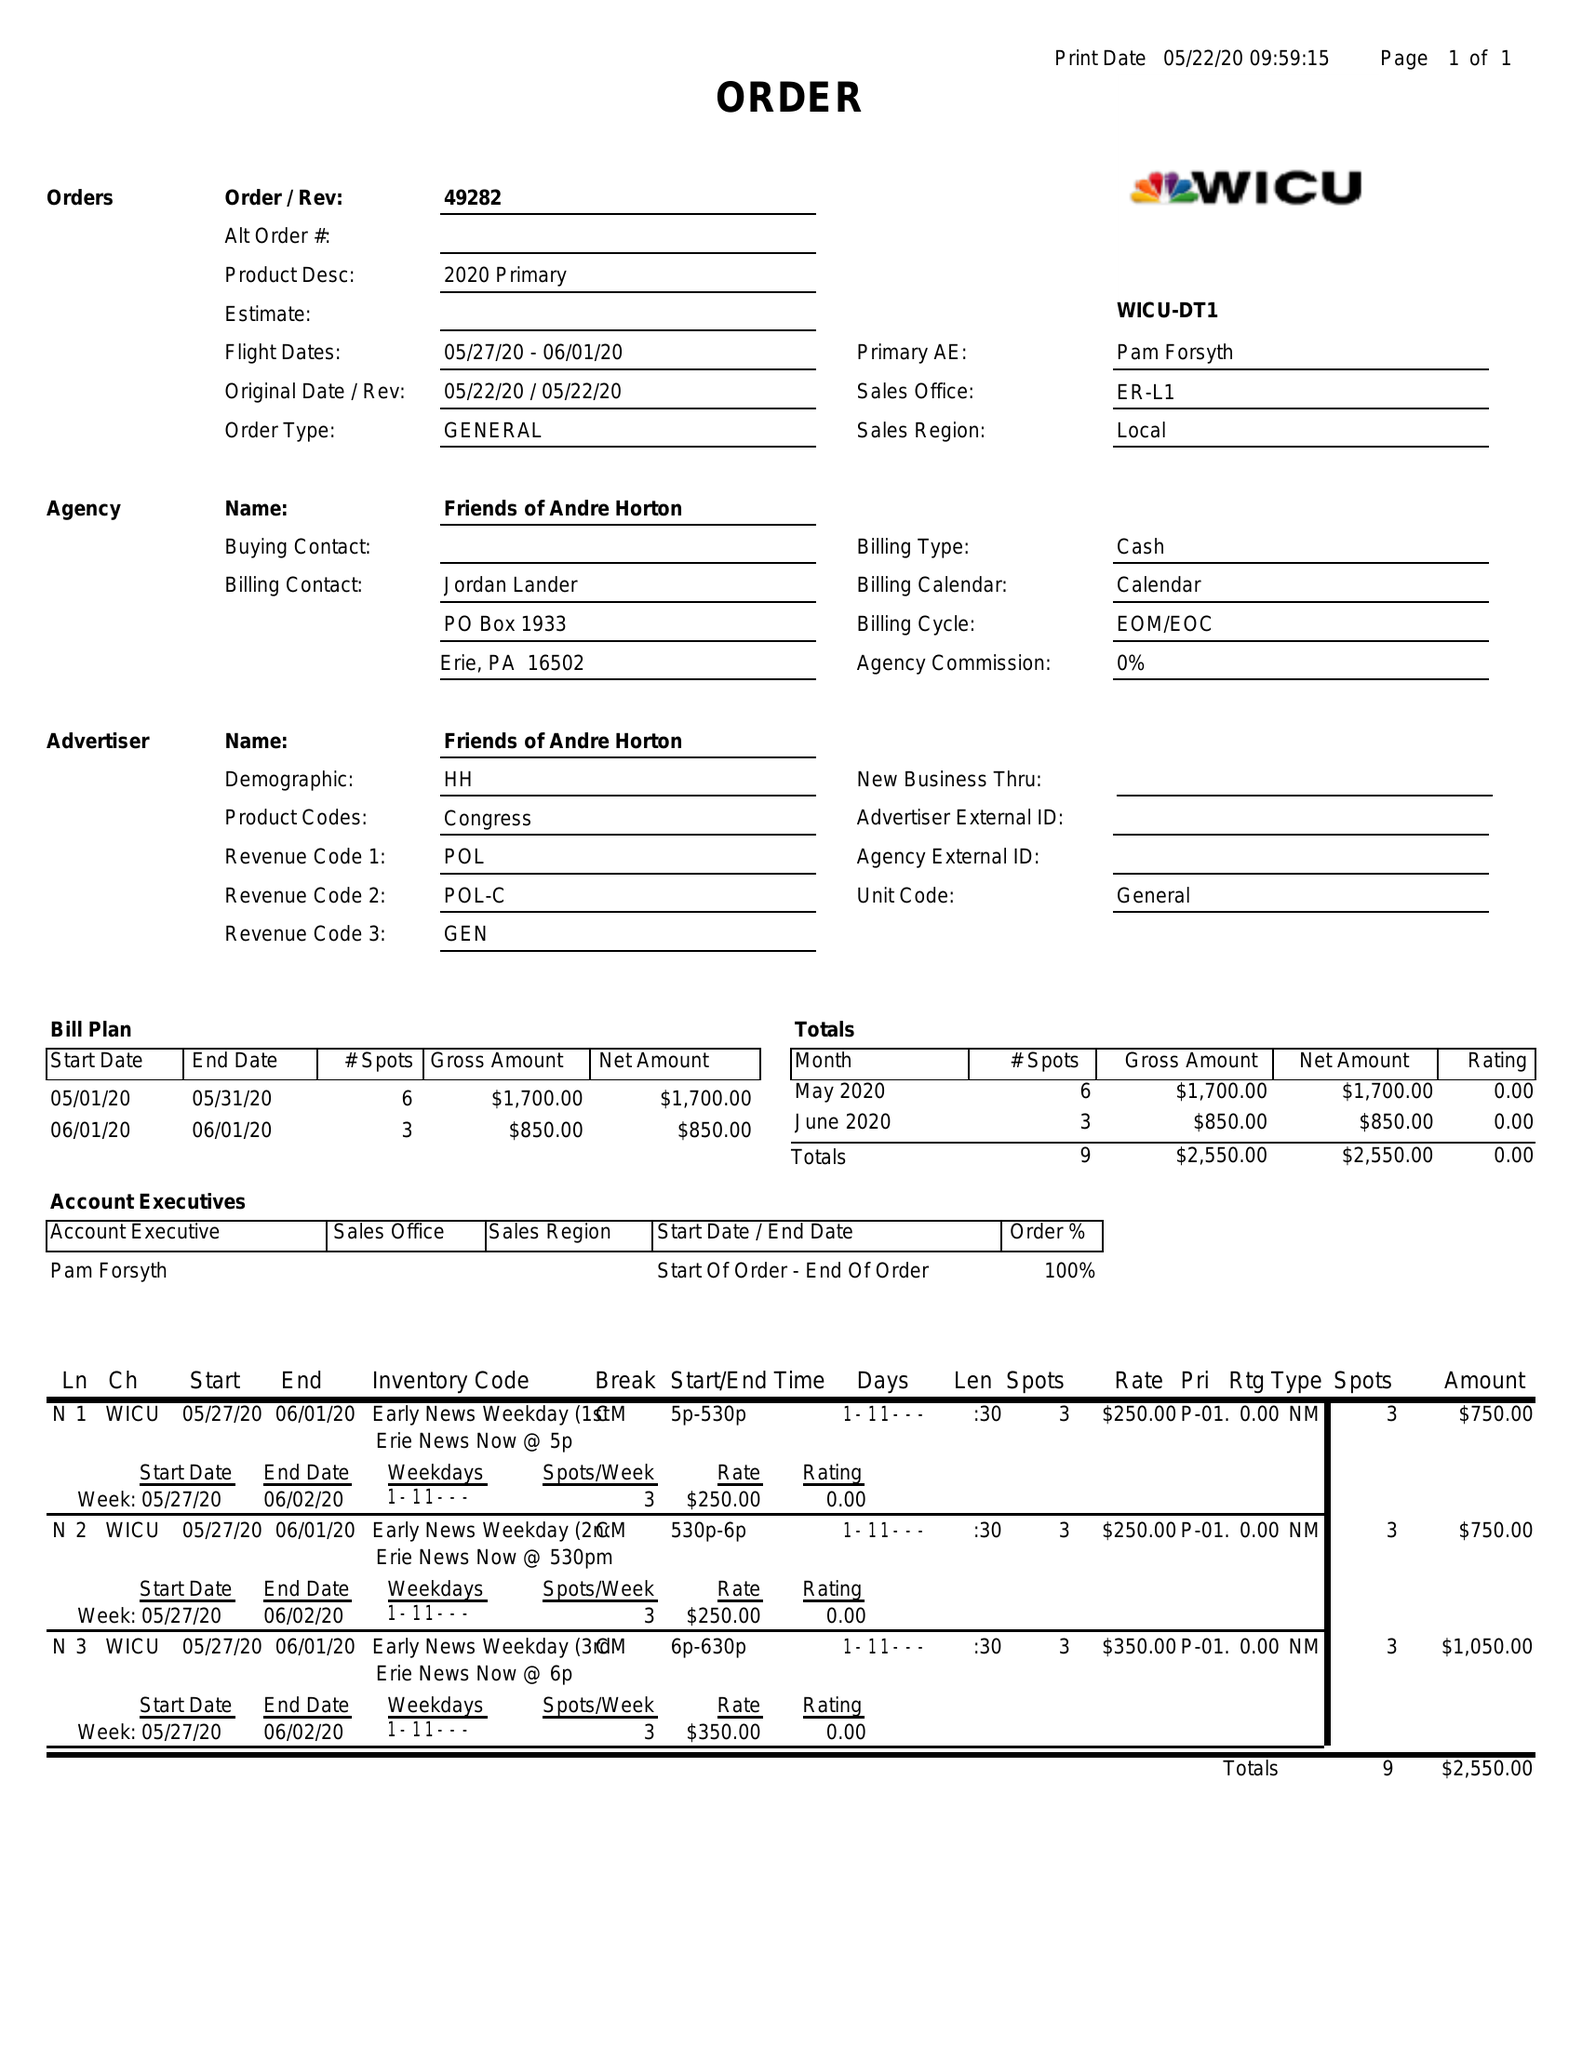What is the value for the contract_num?
Answer the question using a single word or phrase. 49282 